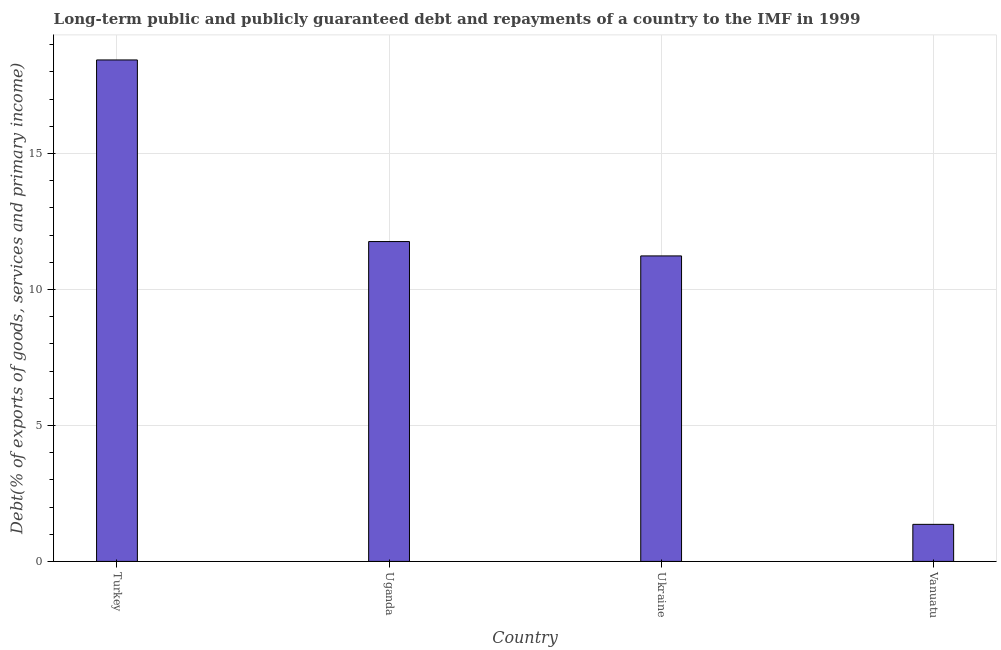What is the title of the graph?
Offer a terse response. Long-term public and publicly guaranteed debt and repayments of a country to the IMF in 1999. What is the label or title of the X-axis?
Your response must be concise. Country. What is the label or title of the Y-axis?
Give a very brief answer. Debt(% of exports of goods, services and primary income). What is the debt service in Vanuatu?
Make the answer very short. 1.36. Across all countries, what is the maximum debt service?
Make the answer very short. 18.44. Across all countries, what is the minimum debt service?
Your answer should be very brief. 1.36. In which country was the debt service maximum?
Offer a terse response. Turkey. In which country was the debt service minimum?
Offer a terse response. Vanuatu. What is the sum of the debt service?
Give a very brief answer. 42.79. What is the difference between the debt service in Turkey and Uganda?
Your answer should be very brief. 6.68. What is the average debt service per country?
Provide a succinct answer. 10.7. What is the median debt service?
Make the answer very short. 11.5. What is the ratio of the debt service in Uganda to that in Vanuatu?
Make the answer very short. 8.63. Is the debt service in Turkey less than that in Ukraine?
Keep it short and to the point. No. What is the difference between the highest and the second highest debt service?
Keep it short and to the point. 6.68. Is the sum of the debt service in Uganda and Vanuatu greater than the maximum debt service across all countries?
Make the answer very short. No. What is the difference between the highest and the lowest debt service?
Provide a succinct answer. 17.07. How many bars are there?
Your answer should be very brief. 4. Are all the bars in the graph horizontal?
Provide a succinct answer. No. Are the values on the major ticks of Y-axis written in scientific E-notation?
Offer a terse response. No. What is the Debt(% of exports of goods, services and primary income) of Turkey?
Provide a short and direct response. 18.44. What is the Debt(% of exports of goods, services and primary income) in Uganda?
Provide a short and direct response. 11.76. What is the Debt(% of exports of goods, services and primary income) in Ukraine?
Give a very brief answer. 11.23. What is the Debt(% of exports of goods, services and primary income) in Vanuatu?
Your response must be concise. 1.36. What is the difference between the Debt(% of exports of goods, services and primary income) in Turkey and Uganda?
Give a very brief answer. 6.68. What is the difference between the Debt(% of exports of goods, services and primary income) in Turkey and Ukraine?
Give a very brief answer. 7.2. What is the difference between the Debt(% of exports of goods, services and primary income) in Turkey and Vanuatu?
Offer a terse response. 17.07. What is the difference between the Debt(% of exports of goods, services and primary income) in Uganda and Ukraine?
Provide a succinct answer. 0.53. What is the difference between the Debt(% of exports of goods, services and primary income) in Uganda and Vanuatu?
Make the answer very short. 10.4. What is the difference between the Debt(% of exports of goods, services and primary income) in Ukraine and Vanuatu?
Your answer should be very brief. 9.87. What is the ratio of the Debt(% of exports of goods, services and primary income) in Turkey to that in Uganda?
Offer a very short reply. 1.57. What is the ratio of the Debt(% of exports of goods, services and primary income) in Turkey to that in Ukraine?
Provide a succinct answer. 1.64. What is the ratio of the Debt(% of exports of goods, services and primary income) in Turkey to that in Vanuatu?
Your answer should be compact. 13.53. What is the ratio of the Debt(% of exports of goods, services and primary income) in Uganda to that in Ukraine?
Keep it short and to the point. 1.05. What is the ratio of the Debt(% of exports of goods, services and primary income) in Uganda to that in Vanuatu?
Provide a short and direct response. 8.63. What is the ratio of the Debt(% of exports of goods, services and primary income) in Ukraine to that in Vanuatu?
Provide a succinct answer. 8.24. 